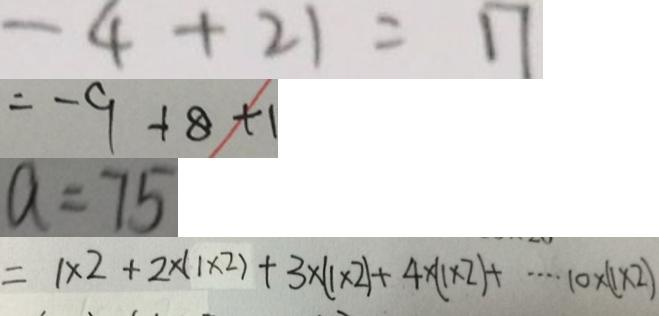Convert formula to latex. <formula><loc_0><loc_0><loc_500><loc_500>- 4 + 2 1 = 1 7 
 = - 9 + 8 + 1 
 a = 7 5 
 = 1 \times 2 + 2 \times ( 1 \times 2 ) + 3 \times ( 1 \times 2 ) + 4 \times ( 1 \times 2 ) + \cdots 1 0 \times ( 1 \times 2 )</formula> 